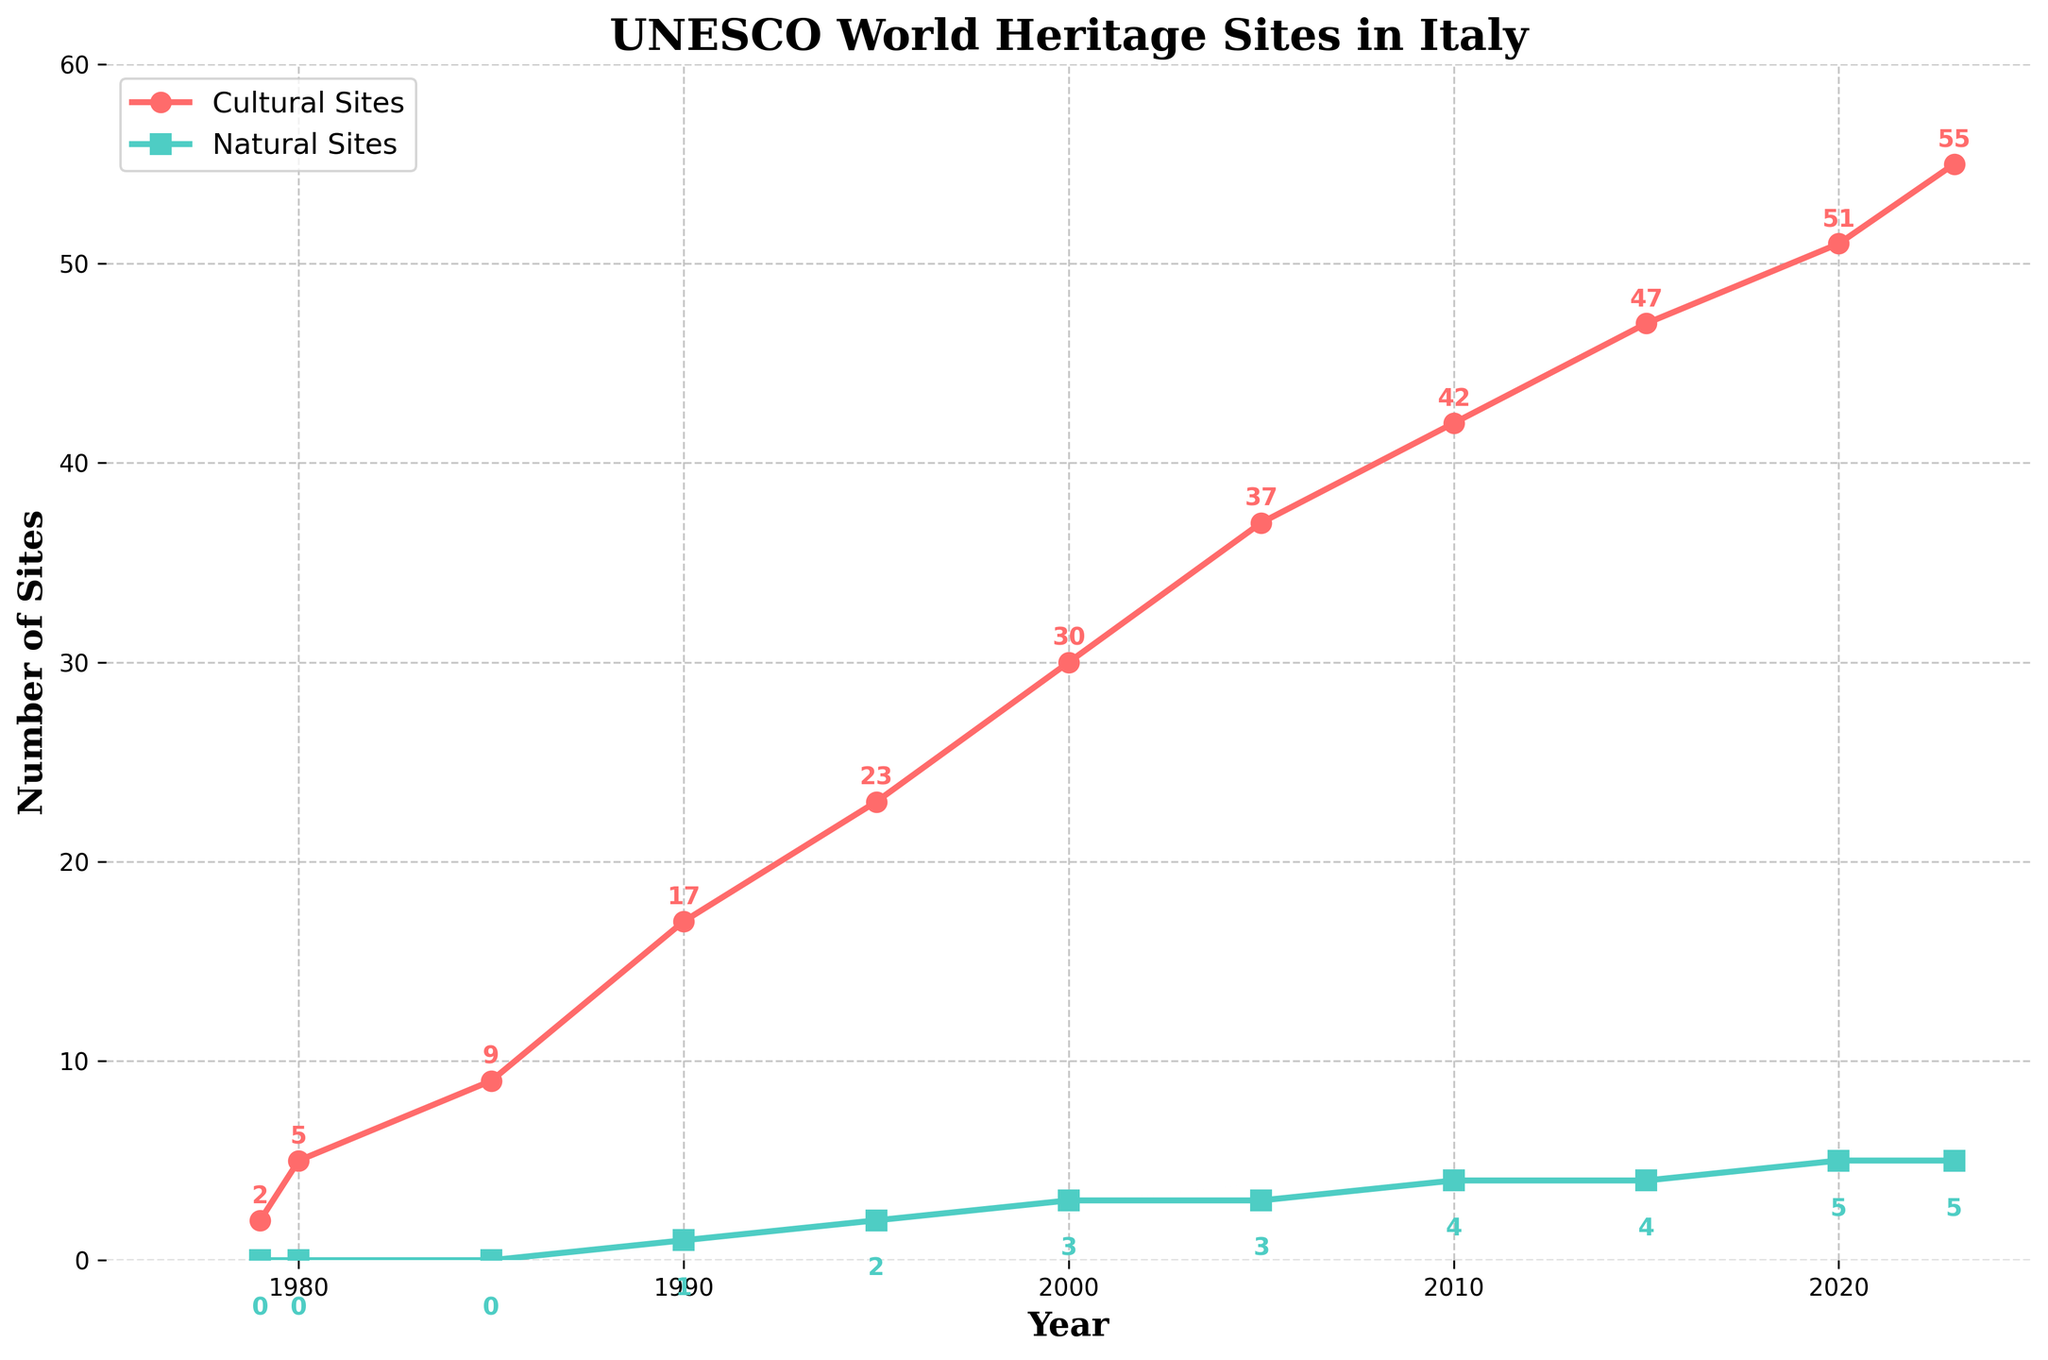What year had the greatest increase in the number of Cultural Sites compared to the previous recorded year? First, calculate the yearly increase by subtracting the number of Cultural Sites from the previous year for each year. The year with the highest increase will be the one with the largest difference. The differences are: 1980-1979 (3), 1985-1980 (4), 1990-1985 (8), 1995-1990 (6), 2000-1995 (7), 2005-2000 (7), 2010-2005 (5), 2015-2010 (5), 2020-2015 (4), 2023-2020 (4). The year 1990 had the greatest increase of 8 sites compared to 1985.
Answer: 1990 How many more Cultural Sites are there compared to Natural Sites in 2023? To find the difference in the number of sites in 2023, subtract the number of Natural Sites from the number of Cultural Sites: 55 (Cultural Sites) - 5 (Natural Sites) = 50. There are 50 more Cultural Sites than Natural Sites in 2023.
Answer: 50 Between which consecutive years did the number of Natural Sites first increase? By observing the Natural Sites line, check the years where the data first changes from one value to a higher value. The first increase occurs between 1985 (0) and 1990 (1).
Answer: 1985-1990 Which category, Cultural Sites or Natural Sites, had more consistent growth over the years? Assess the steadiness of the increments for both categories by examining the gaps between points on their respective lines. The Cultural Sites line shows a more consistent upward trend with regular increments, while the Natural Sites line has fewer increases and longer periods of stagnation.
Answer: Cultural Sites How many Natural Sites were added in total between 1979 and 2023? Sum the differences in the number of Natural Sites across all these years by observing each increase: from 0 to 1 (1990), 1 to 2 (1995), 2 to 3 (2000), 3 to 4 (2010), and 4 to 5 (2020). The natural sites increased by 1 five times.
Answer: 5 In which years was the number of Cultural Sites exactly 37? By looking at the Cultural Sites line, the point corresponding to 37 sites can be identified. The year where this happens is 2005.
Answer: 2005 How many years did it take for the number of Cultural Sites to go from 30 to 55? Identify the years where these two values occur and subtract the earlier year from the later year: from 2000 (30 sites) to 2023 (55 sites), the number of years is 2023 - 2000 = 23.
Answer: 23 What is the average number of Cultural Sites added per year over the entire period? The total number of Cultural Sites added from 1979 to 2023 is 55 - 2 = 53. There are 2023 - 1979 = 44 years in this period. The average rate of addition is 53 / 44 ≈ 1.20 sites per year.
Answer: 1.20 